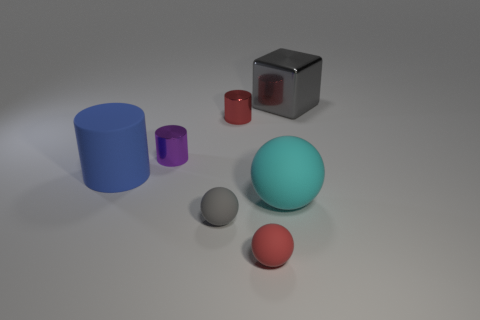Add 2 small shiny cylinders. How many objects exist? 9 Subtract all cylinders. How many objects are left? 4 Subtract all tiny blue objects. Subtract all large gray metallic things. How many objects are left? 6 Add 5 small red spheres. How many small red spheres are left? 6 Add 6 tiny red metallic things. How many tiny red metallic things exist? 7 Subtract 0 green balls. How many objects are left? 7 